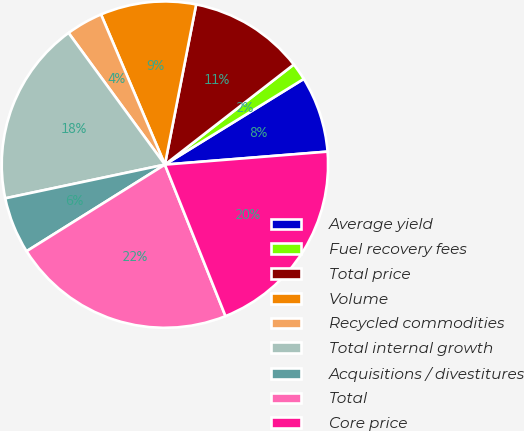Convert chart. <chart><loc_0><loc_0><loc_500><loc_500><pie_chart><fcel>Average yield<fcel>Fuel recovery fees<fcel>Total price<fcel>Volume<fcel>Recycled commodities<fcel>Total internal growth<fcel>Acquisitions / divestitures<fcel>Total<fcel>Core price<nl><fcel>7.53%<fcel>1.71%<fcel>11.42%<fcel>9.47%<fcel>3.65%<fcel>18.26%<fcel>5.59%<fcel>22.15%<fcel>20.21%<nl></chart> 